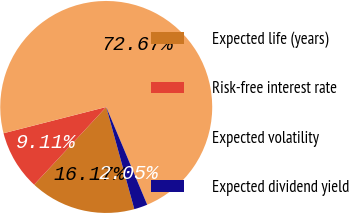Convert chart to OTSL. <chart><loc_0><loc_0><loc_500><loc_500><pie_chart><fcel>Expected life (years)<fcel>Risk-free interest rate<fcel>Expected volatility<fcel>Expected dividend yield<nl><fcel>16.17%<fcel>9.11%<fcel>72.67%<fcel>2.05%<nl></chart> 